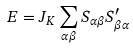Convert formula to latex. <formula><loc_0><loc_0><loc_500><loc_500>E = J _ { K } \sum _ { \alpha \beta } S _ { \alpha \beta } S ^ { \prime } _ { \beta \alpha }</formula> 